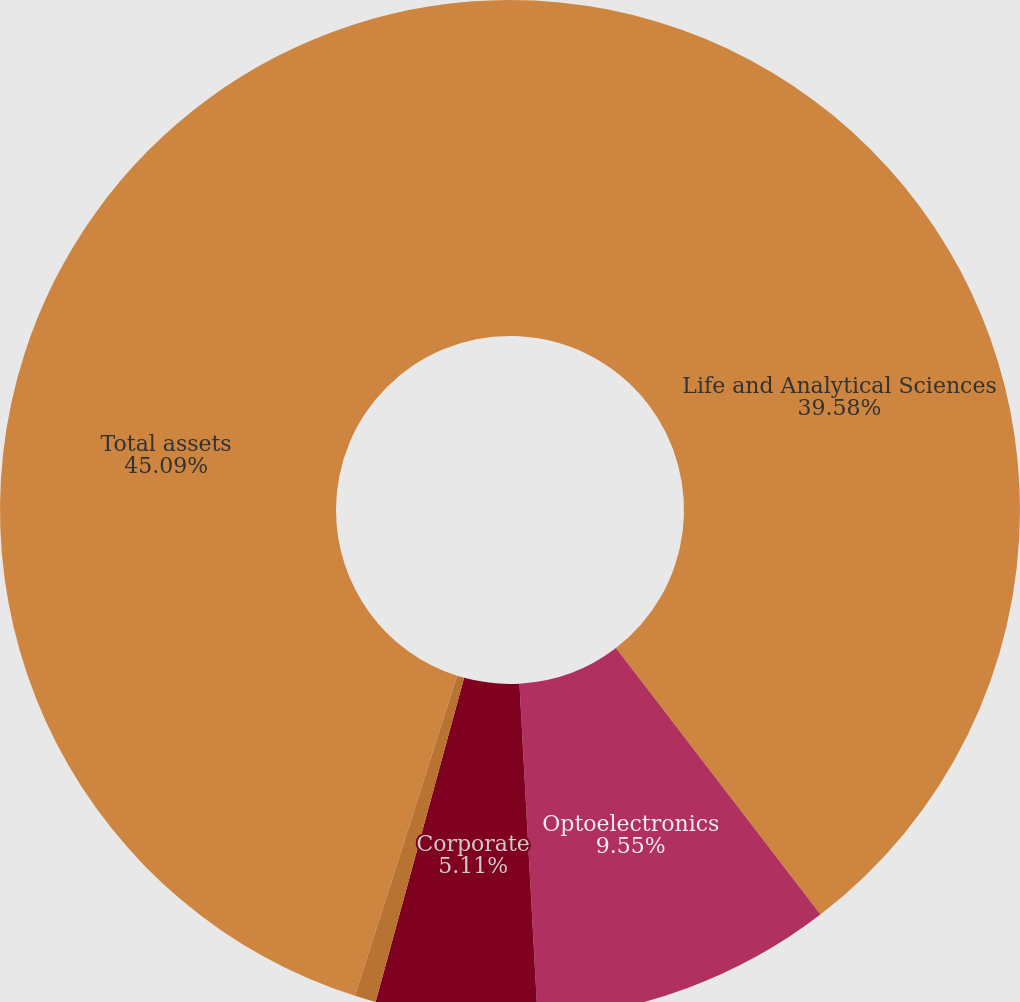Convert chart to OTSL. <chart><loc_0><loc_0><loc_500><loc_500><pie_chart><fcel>Life and Analytical Sciences<fcel>Optoelectronics<fcel>Corporate<fcel>Net current and long-term<fcel>Total assets<nl><fcel>39.58%<fcel>9.55%<fcel>5.11%<fcel>0.67%<fcel>45.08%<nl></chart> 